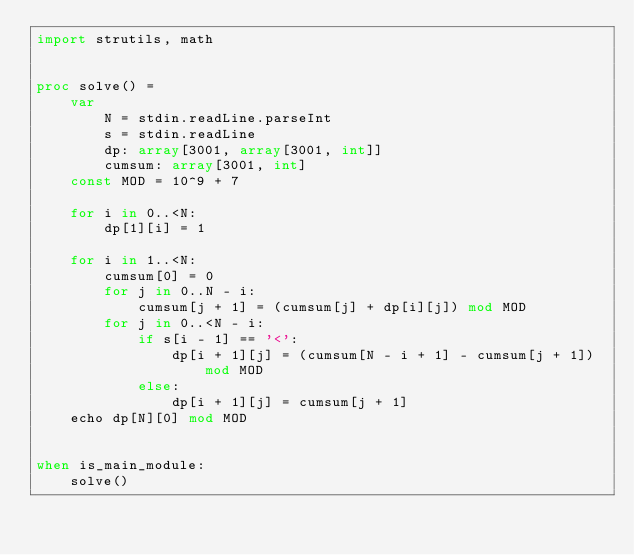Convert code to text. <code><loc_0><loc_0><loc_500><loc_500><_Nim_>import strutils, math


proc solve() =
    var
        N = stdin.readLine.parseInt
        s = stdin.readLine
        dp: array[3001, array[3001, int]]
        cumsum: array[3001, int]
    const MOD = 10^9 + 7
    
    for i in 0..<N:
        dp[1][i] = 1
    
    for i in 1..<N:
        cumsum[0] = 0
        for j in 0..N - i:
            cumsum[j + 1] = (cumsum[j] + dp[i][j]) mod MOD
        for j in 0..<N - i:
            if s[i - 1] == '<':
                dp[i + 1][j] = (cumsum[N - i + 1] - cumsum[j + 1]) mod MOD
            else:
                dp[i + 1][j] = cumsum[j + 1]
    echo dp[N][0] mod MOD


when is_main_module:
    solve()
</code> 